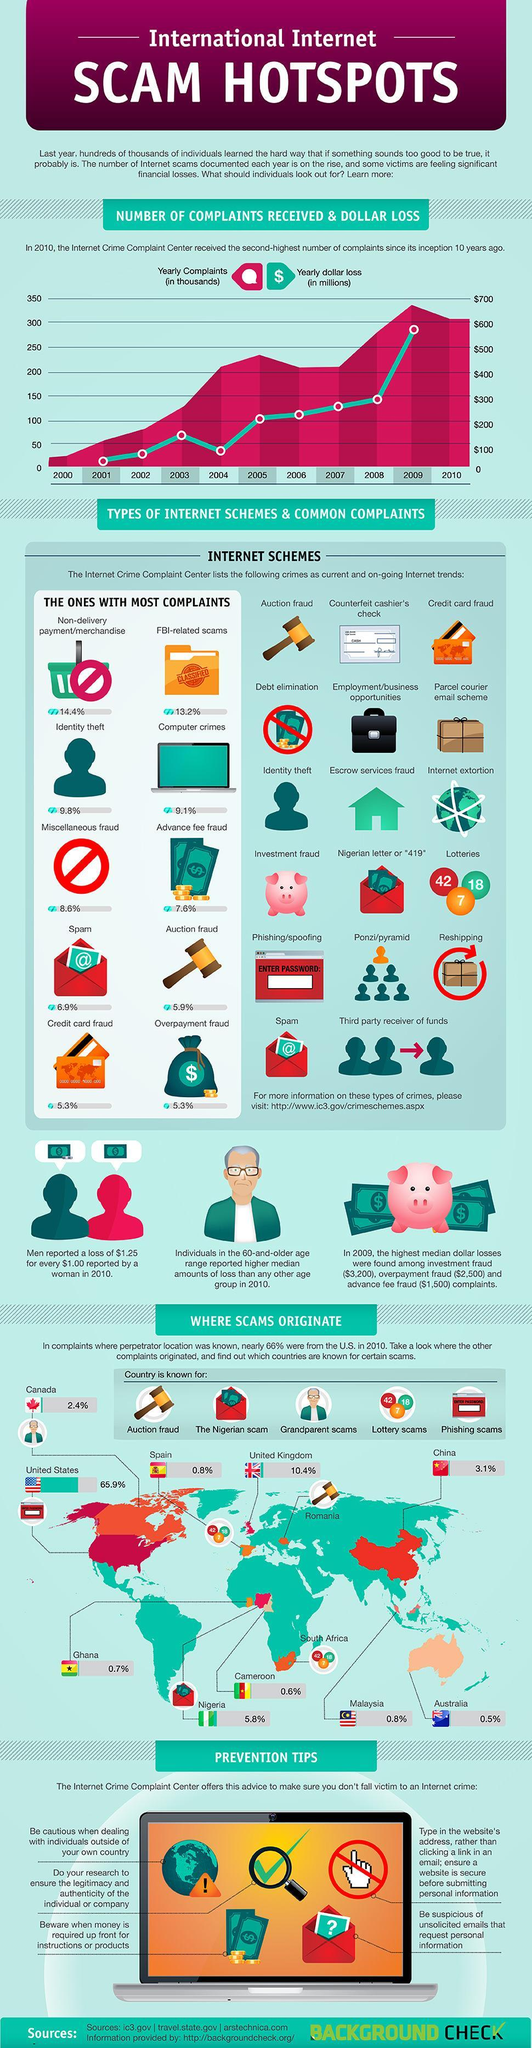Which year marks a drop in yearly dollar loss from the consistent increase since 2001?
Answer the question with a short phrase. 2004 What is the percentage of FBI-related scams? 13.2% Which country has the lowest rate of internet crimes, Australia, Cameroon, or Malaysia? Australia Which frauds have a complaint rate of 5.3%? Credit card fraud, Overpayment fraud How many types of internet based frauds have the most complaints? 10 